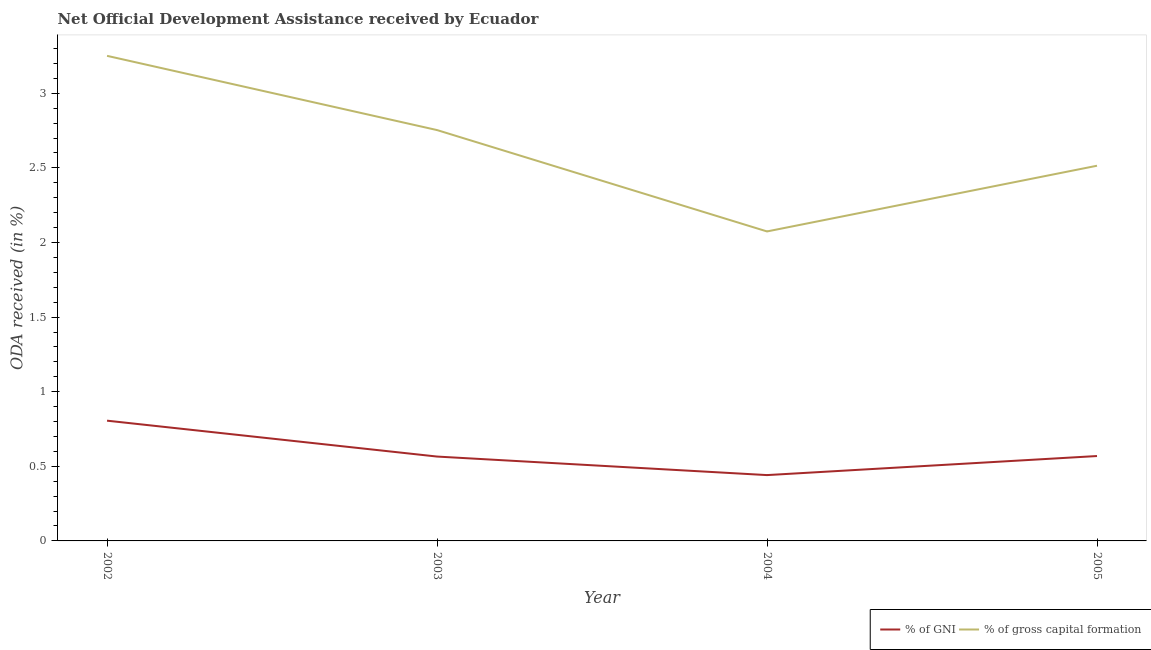Is the number of lines equal to the number of legend labels?
Ensure brevity in your answer.  Yes. What is the oda received as percentage of gross capital formation in 2003?
Your answer should be compact. 2.75. Across all years, what is the maximum oda received as percentage of gross capital formation?
Your response must be concise. 3.25. Across all years, what is the minimum oda received as percentage of gross capital formation?
Offer a very short reply. 2.07. In which year was the oda received as percentage of gni maximum?
Provide a short and direct response. 2002. In which year was the oda received as percentage of gross capital formation minimum?
Provide a succinct answer. 2004. What is the total oda received as percentage of gross capital formation in the graph?
Provide a short and direct response. 10.59. What is the difference between the oda received as percentage of gross capital formation in 2002 and that in 2005?
Give a very brief answer. 0.74. What is the difference between the oda received as percentage of gni in 2003 and the oda received as percentage of gross capital formation in 2002?
Your answer should be very brief. -2.69. What is the average oda received as percentage of gross capital formation per year?
Ensure brevity in your answer.  2.65. In the year 2002, what is the difference between the oda received as percentage of gni and oda received as percentage of gross capital formation?
Provide a succinct answer. -2.44. In how many years, is the oda received as percentage of gross capital formation greater than 2.8 %?
Keep it short and to the point. 1. What is the ratio of the oda received as percentage of gross capital formation in 2003 to that in 2005?
Offer a terse response. 1.1. Is the difference between the oda received as percentage of gross capital formation in 2002 and 2005 greater than the difference between the oda received as percentage of gni in 2002 and 2005?
Keep it short and to the point. Yes. What is the difference between the highest and the second highest oda received as percentage of gross capital formation?
Offer a terse response. 0.5. What is the difference between the highest and the lowest oda received as percentage of gross capital formation?
Offer a very short reply. 1.18. In how many years, is the oda received as percentage of gni greater than the average oda received as percentage of gni taken over all years?
Your answer should be compact. 1. Does the oda received as percentage of gni monotonically increase over the years?
Your answer should be compact. No. Is the oda received as percentage of gni strictly greater than the oda received as percentage of gross capital formation over the years?
Your answer should be very brief. No. How many years are there in the graph?
Make the answer very short. 4. What is the difference between two consecutive major ticks on the Y-axis?
Give a very brief answer. 0.5. Are the values on the major ticks of Y-axis written in scientific E-notation?
Your answer should be compact. No. Does the graph contain grids?
Offer a terse response. No. How many legend labels are there?
Make the answer very short. 2. What is the title of the graph?
Keep it short and to the point. Net Official Development Assistance received by Ecuador. Does "GDP at market prices" appear as one of the legend labels in the graph?
Provide a succinct answer. No. What is the label or title of the Y-axis?
Offer a terse response. ODA received (in %). What is the ODA received (in %) of % of GNI in 2002?
Make the answer very short. 0.81. What is the ODA received (in %) in % of gross capital formation in 2002?
Offer a very short reply. 3.25. What is the ODA received (in %) of % of GNI in 2003?
Provide a succinct answer. 0.57. What is the ODA received (in %) in % of gross capital formation in 2003?
Give a very brief answer. 2.75. What is the ODA received (in %) in % of GNI in 2004?
Your answer should be very brief. 0.44. What is the ODA received (in %) of % of gross capital formation in 2004?
Offer a very short reply. 2.07. What is the ODA received (in %) of % of GNI in 2005?
Make the answer very short. 0.57. What is the ODA received (in %) in % of gross capital formation in 2005?
Your response must be concise. 2.51. Across all years, what is the maximum ODA received (in %) of % of GNI?
Your answer should be compact. 0.81. Across all years, what is the maximum ODA received (in %) in % of gross capital formation?
Provide a succinct answer. 3.25. Across all years, what is the minimum ODA received (in %) of % of GNI?
Your answer should be compact. 0.44. Across all years, what is the minimum ODA received (in %) in % of gross capital formation?
Ensure brevity in your answer.  2.07. What is the total ODA received (in %) in % of GNI in the graph?
Offer a terse response. 2.38. What is the total ODA received (in %) in % of gross capital formation in the graph?
Provide a succinct answer. 10.59. What is the difference between the ODA received (in %) of % of GNI in 2002 and that in 2003?
Provide a short and direct response. 0.24. What is the difference between the ODA received (in %) in % of gross capital formation in 2002 and that in 2003?
Ensure brevity in your answer.  0.5. What is the difference between the ODA received (in %) of % of GNI in 2002 and that in 2004?
Make the answer very short. 0.36. What is the difference between the ODA received (in %) in % of gross capital formation in 2002 and that in 2004?
Offer a terse response. 1.18. What is the difference between the ODA received (in %) in % of GNI in 2002 and that in 2005?
Provide a succinct answer. 0.24. What is the difference between the ODA received (in %) in % of gross capital formation in 2002 and that in 2005?
Offer a very short reply. 0.74. What is the difference between the ODA received (in %) of % of GNI in 2003 and that in 2004?
Your answer should be compact. 0.12. What is the difference between the ODA received (in %) of % of gross capital formation in 2003 and that in 2004?
Your response must be concise. 0.68. What is the difference between the ODA received (in %) of % of GNI in 2003 and that in 2005?
Your answer should be compact. -0. What is the difference between the ODA received (in %) in % of gross capital formation in 2003 and that in 2005?
Ensure brevity in your answer.  0.24. What is the difference between the ODA received (in %) in % of GNI in 2004 and that in 2005?
Give a very brief answer. -0.13. What is the difference between the ODA received (in %) of % of gross capital formation in 2004 and that in 2005?
Keep it short and to the point. -0.44. What is the difference between the ODA received (in %) in % of GNI in 2002 and the ODA received (in %) in % of gross capital formation in 2003?
Your answer should be compact. -1.95. What is the difference between the ODA received (in %) in % of GNI in 2002 and the ODA received (in %) in % of gross capital formation in 2004?
Your answer should be compact. -1.27. What is the difference between the ODA received (in %) in % of GNI in 2002 and the ODA received (in %) in % of gross capital formation in 2005?
Make the answer very short. -1.71. What is the difference between the ODA received (in %) of % of GNI in 2003 and the ODA received (in %) of % of gross capital formation in 2004?
Give a very brief answer. -1.51. What is the difference between the ODA received (in %) in % of GNI in 2003 and the ODA received (in %) in % of gross capital formation in 2005?
Provide a short and direct response. -1.95. What is the difference between the ODA received (in %) of % of GNI in 2004 and the ODA received (in %) of % of gross capital formation in 2005?
Offer a terse response. -2.07. What is the average ODA received (in %) of % of GNI per year?
Offer a terse response. 0.6. What is the average ODA received (in %) of % of gross capital formation per year?
Give a very brief answer. 2.65. In the year 2002, what is the difference between the ODA received (in %) of % of GNI and ODA received (in %) of % of gross capital formation?
Keep it short and to the point. -2.44. In the year 2003, what is the difference between the ODA received (in %) in % of GNI and ODA received (in %) in % of gross capital formation?
Your response must be concise. -2.19. In the year 2004, what is the difference between the ODA received (in %) in % of GNI and ODA received (in %) in % of gross capital formation?
Provide a succinct answer. -1.63. In the year 2005, what is the difference between the ODA received (in %) in % of GNI and ODA received (in %) in % of gross capital formation?
Your answer should be very brief. -1.95. What is the ratio of the ODA received (in %) in % of GNI in 2002 to that in 2003?
Keep it short and to the point. 1.43. What is the ratio of the ODA received (in %) in % of gross capital formation in 2002 to that in 2003?
Keep it short and to the point. 1.18. What is the ratio of the ODA received (in %) in % of GNI in 2002 to that in 2004?
Offer a terse response. 1.83. What is the ratio of the ODA received (in %) of % of gross capital formation in 2002 to that in 2004?
Your answer should be compact. 1.57. What is the ratio of the ODA received (in %) of % of GNI in 2002 to that in 2005?
Offer a very short reply. 1.42. What is the ratio of the ODA received (in %) of % of gross capital formation in 2002 to that in 2005?
Give a very brief answer. 1.29. What is the ratio of the ODA received (in %) of % of GNI in 2003 to that in 2004?
Keep it short and to the point. 1.28. What is the ratio of the ODA received (in %) of % of gross capital formation in 2003 to that in 2004?
Give a very brief answer. 1.33. What is the ratio of the ODA received (in %) in % of gross capital formation in 2003 to that in 2005?
Make the answer very short. 1.09. What is the ratio of the ODA received (in %) in % of GNI in 2004 to that in 2005?
Keep it short and to the point. 0.78. What is the ratio of the ODA received (in %) in % of gross capital formation in 2004 to that in 2005?
Your answer should be compact. 0.82. What is the difference between the highest and the second highest ODA received (in %) of % of GNI?
Your response must be concise. 0.24. What is the difference between the highest and the second highest ODA received (in %) in % of gross capital formation?
Provide a short and direct response. 0.5. What is the difference between the highest and the lowest ODA received (in %) in % of GNI?
Provide a short and direct response. 0.36. What is the difference between the highest and the lowest ODA received (in %) of % of gross capital formation?
Keep it short and to the point. 1.18. 